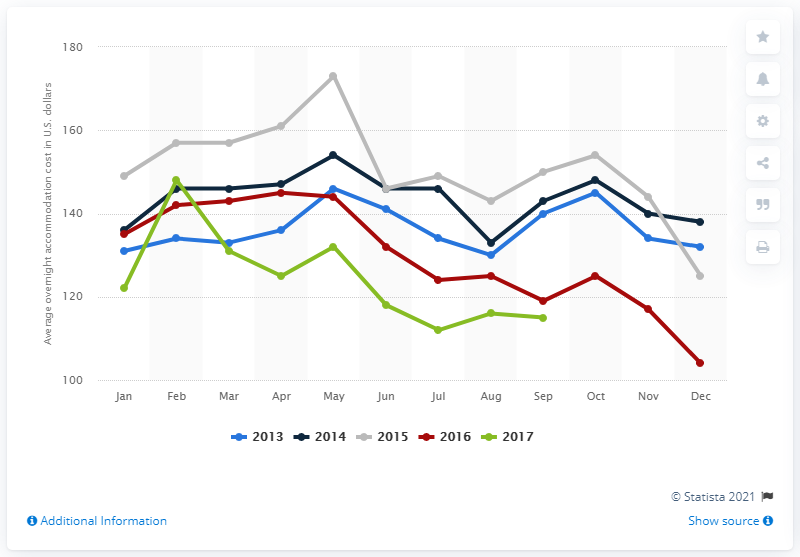Indicate a few pertinent items in this graphic. According to data collected in July 2017, the average cost of overnight accommodation in Houston was 112. 